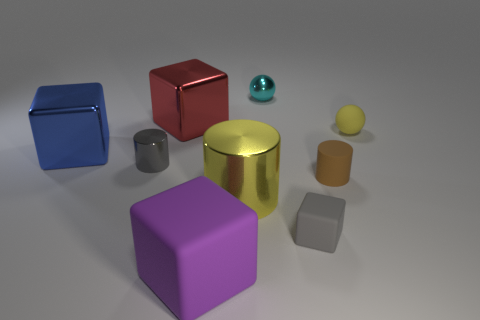Subtract 1 blocks. How many blocks are left? 3 Subtract all tiny cylinders. How many cylinders are left? 1 Subtract all yellow blocks. Subtract all green balls. How many blocks are left? 4 Subtract all cylinders. How many objects are left? 6 Add 4 big yellow metallic things. How many big yellow metallic things are left? 5 Add 6 tiny red blocks. How many tiny red blocks exist? 6 Subtract 1 purple blocks. How many objects are left? 8 Subtract all gray metallic objects. Subtract all big blue metal blocks. How many objects are left? 7 